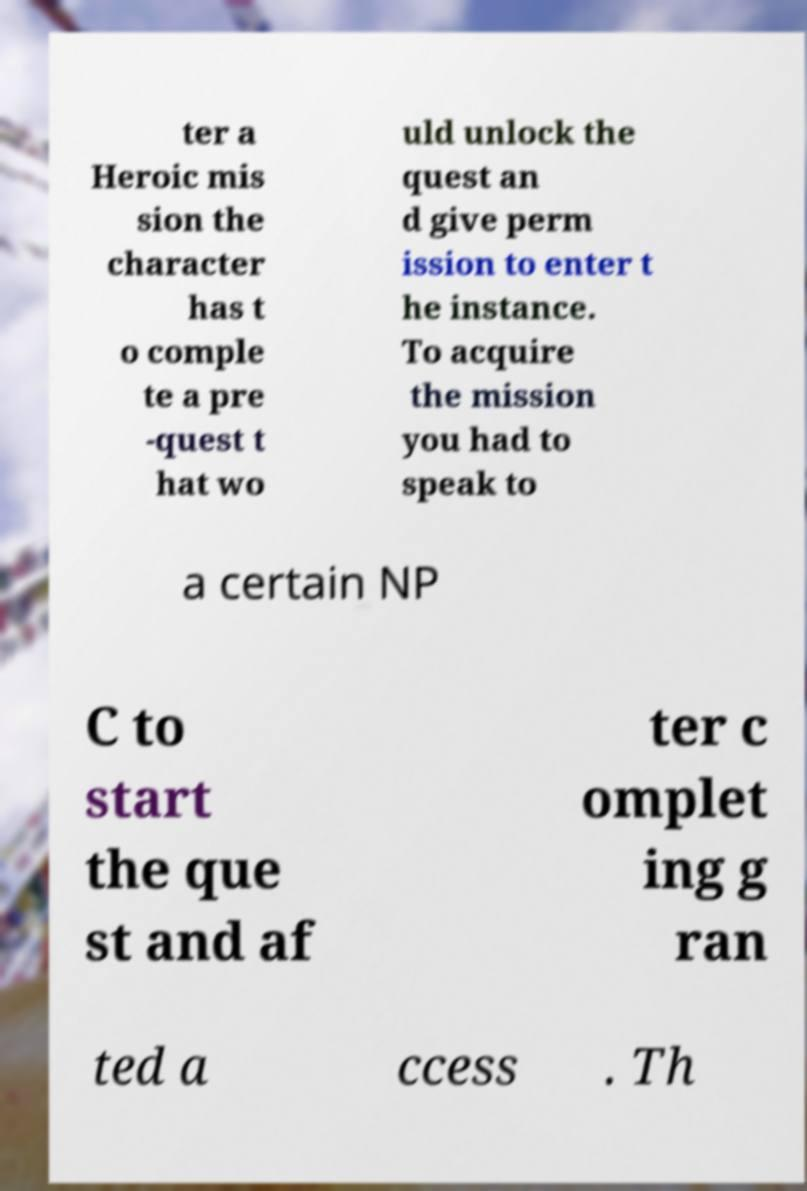For documentation purposes, I need the text within this image transcribed. Could you provide that? ter a Heroic mis sion the character has t o comple te a pre -quest t hat wo uld unlock the quest an d give perm ission to enter t he instance. To acquire the mission you had to speak to a certain NP C to start the que st and af ter c omplet ing g ran ted a ccess . Th 